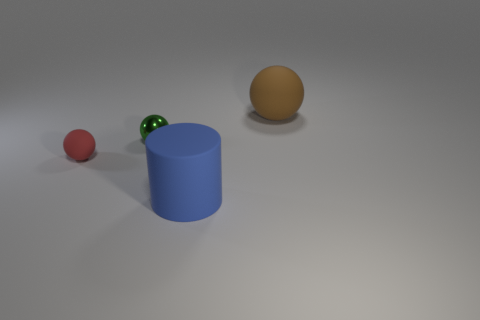Is the color of the small rubber ball the same as the cylinder? no 